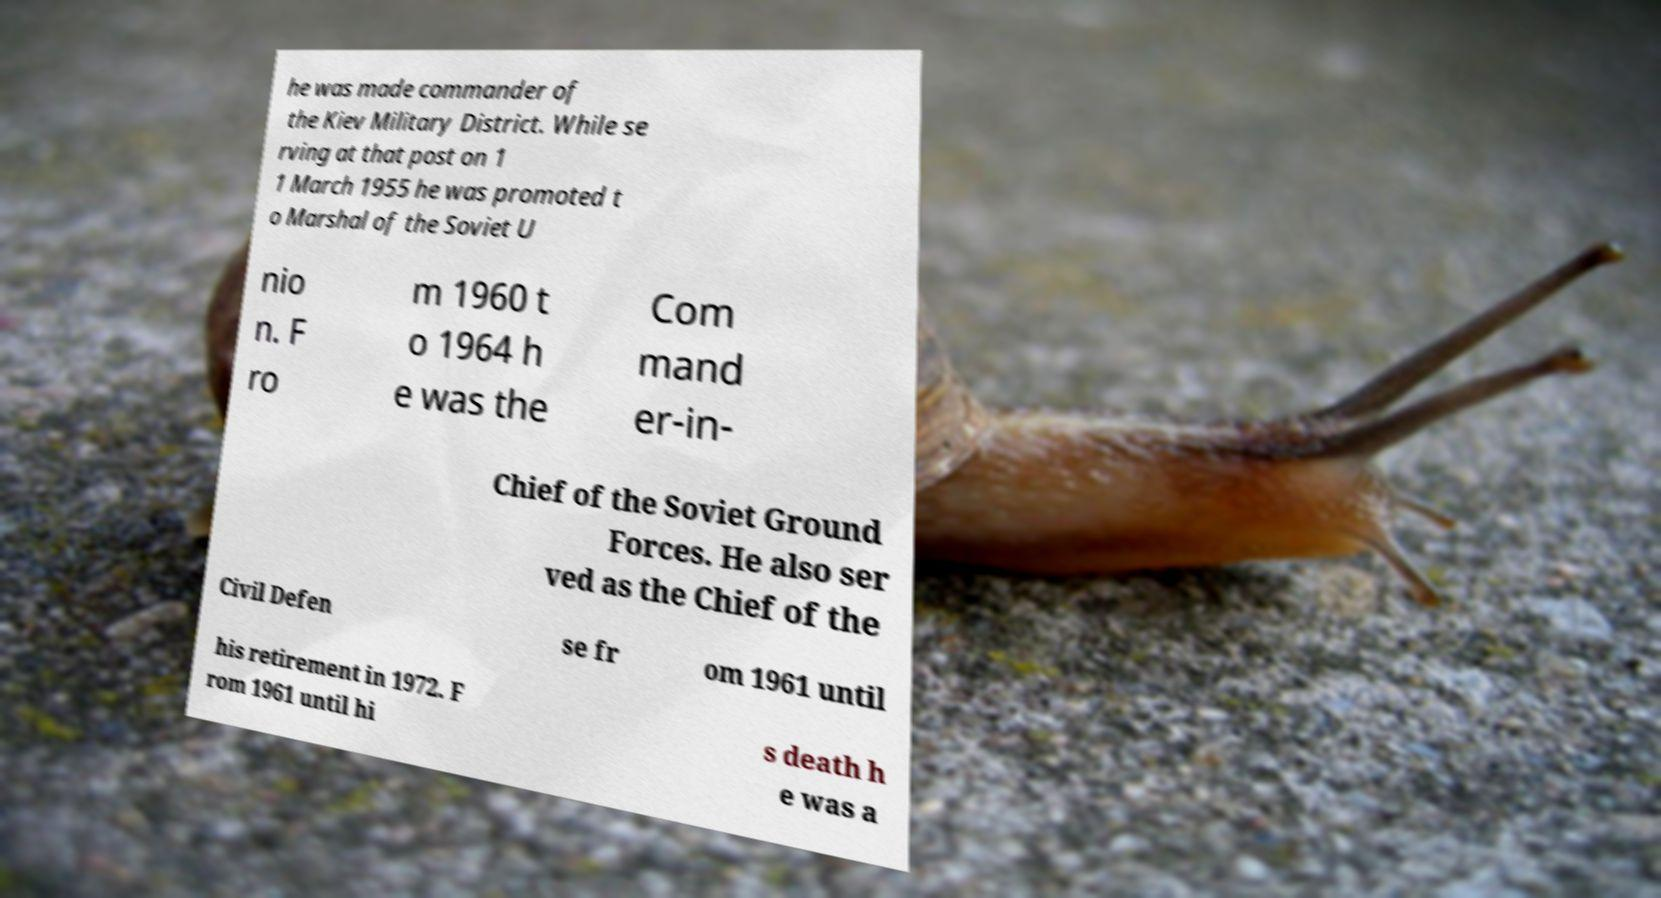Could you assist in decoding the text presented in this image and type it out clearly? he was made commander of the Kiev Military District. While se rving at that post on 1 1 March 1955 he was promoted t o Marshal of the Soviet U nio n. F ro m 1960 t o 1964 h e was the Com mand er-in- Chief of the Soviet Ground Forces. He also ser ved as the Chief of the Civil Defen se fr om 1961 until his retirement in 1972. F rom 1961 until hi s death h e was a 